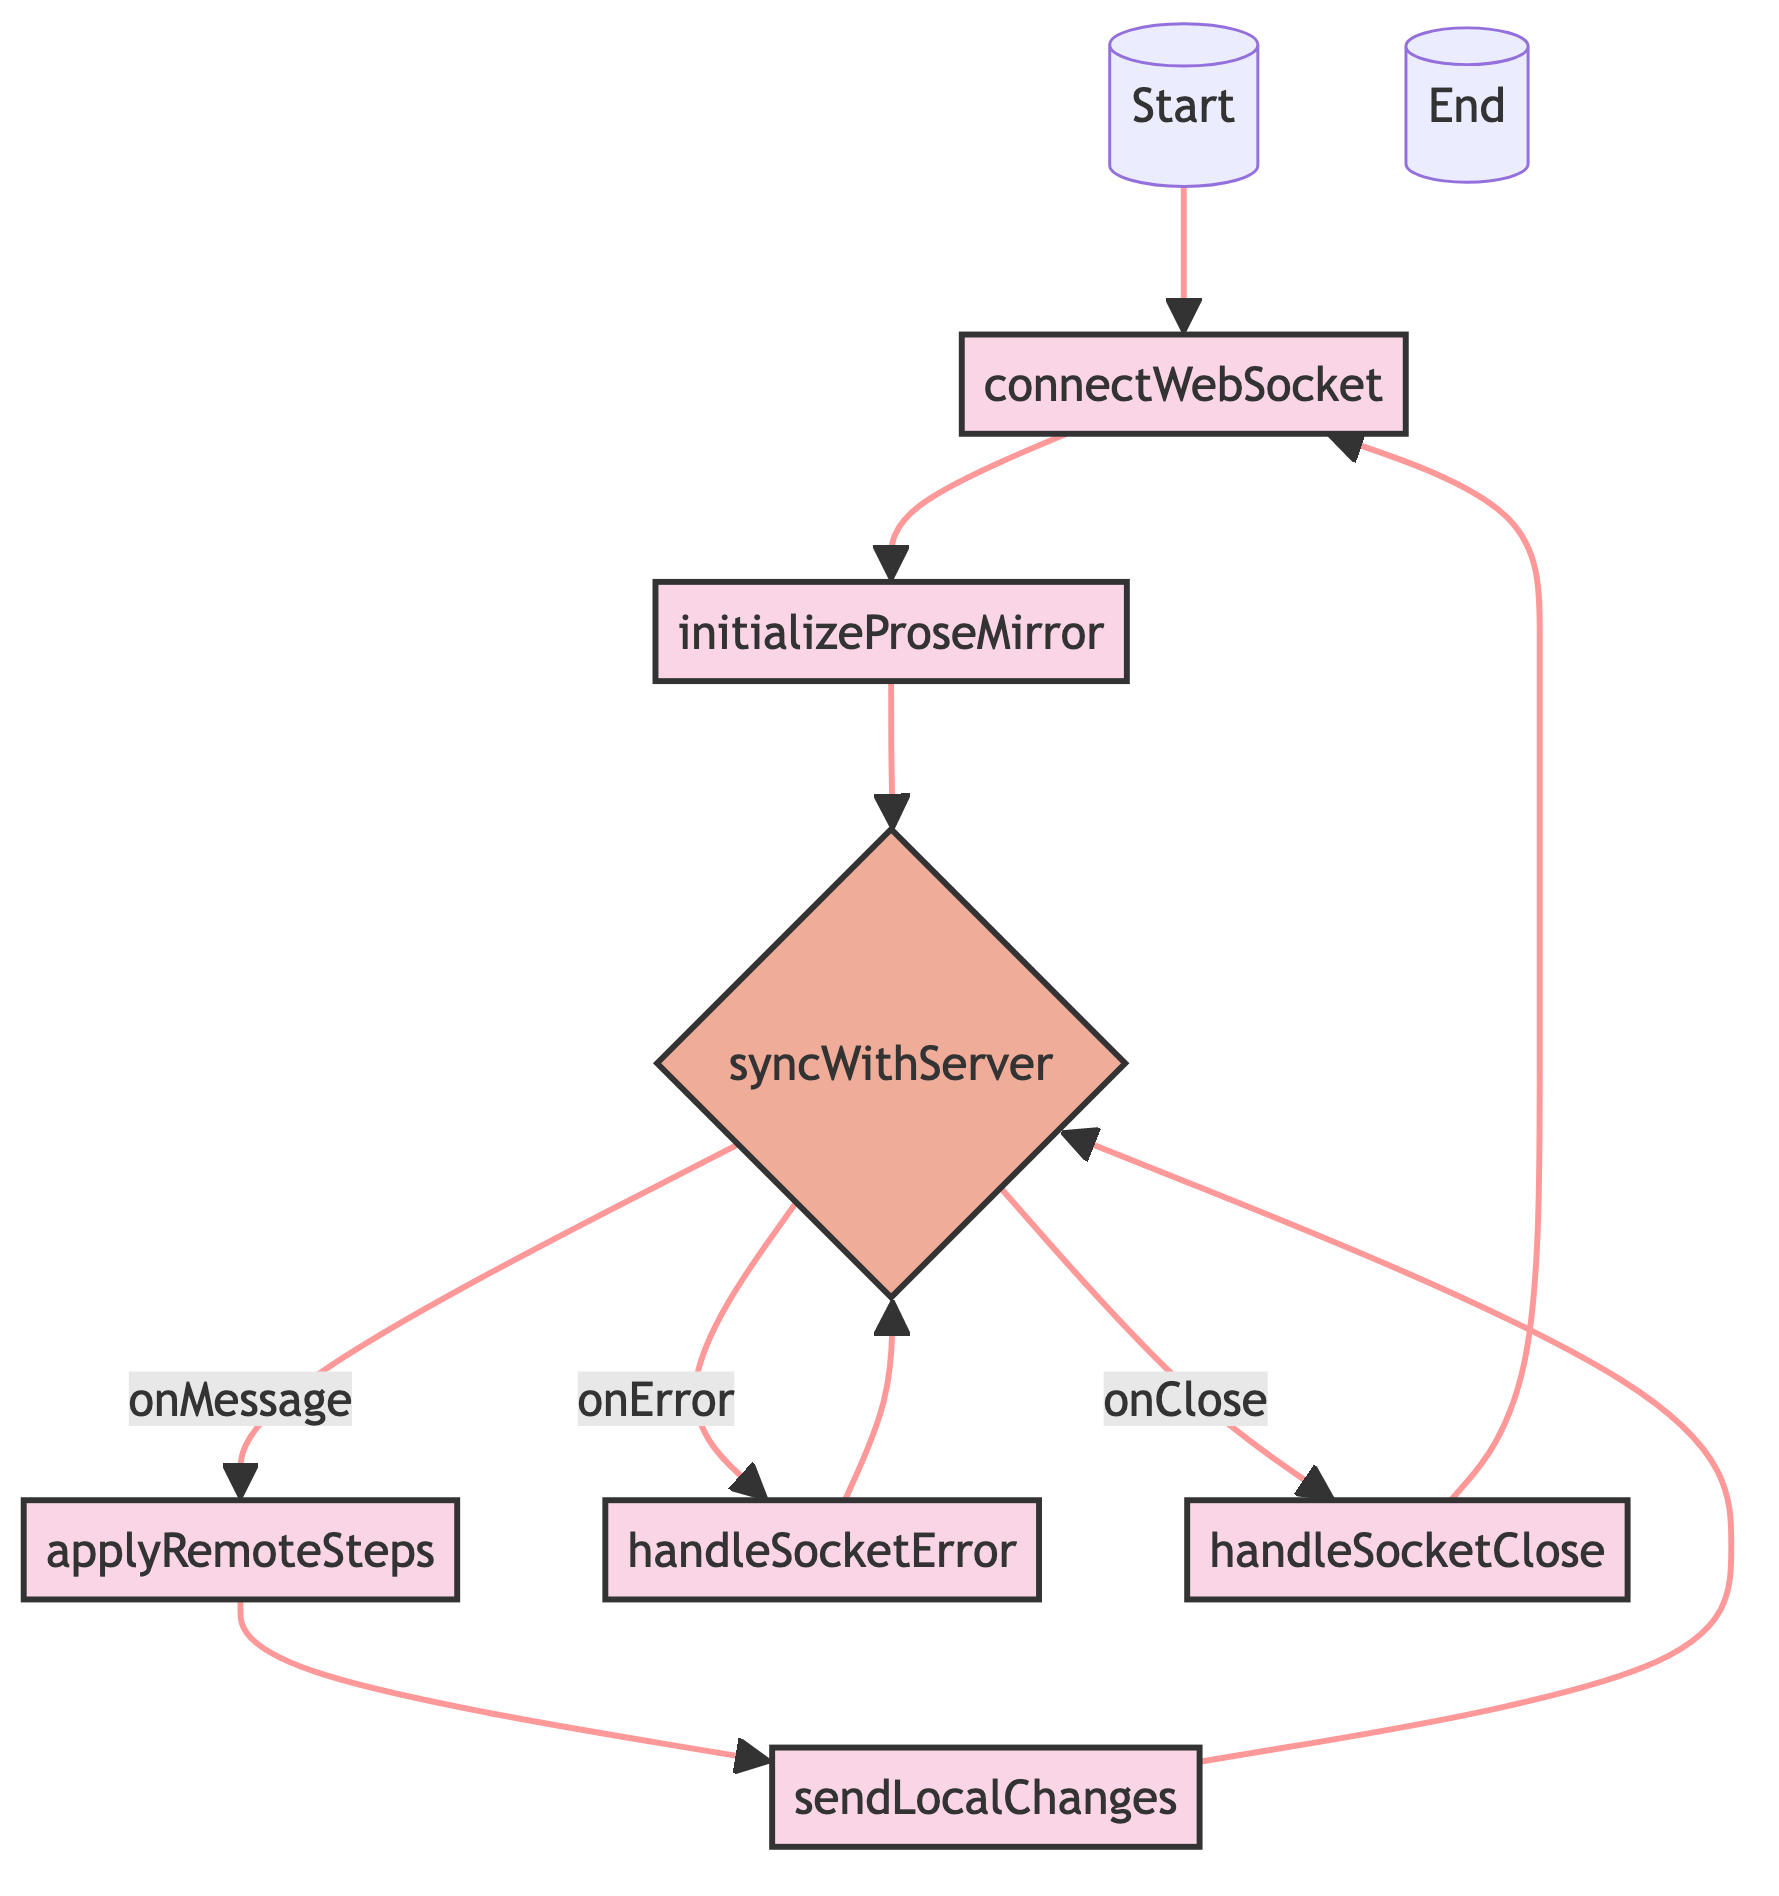What is the first action in the flowchart? The flowchart starts with the node "connectWebSocket," which is the first action taken to establish a WebSocket connection.
Answer: connectWebSocket How many actions are present in the flowchart? The flowchart has six actions: connectWebSocket, initializeProseMirror, applyRemoteSteps, sendLocalChanges, handleSocketError, and handleSocketClose.
Answer: six What happens after initializing ProseMirror? After initializing ProseMirror, the next step is to sync with the server using the "syncWithServer" decision node.
Answer: syncWithServer What is the action taken when a message is received from the server? When a message is received, the action taken is "applyRemoteSteps," which applies remote steps to the local ProseMirror editor.
Answer: applyRemoteSteps What do we do when the WebSocket connection encounters an error? In case of a WebSocket error, the action "handleSocketError" is executed to log or display error messages.
Answer: handleSocketError Which node do we return to after handling a socket closure? After handling a socket closure with "handleSocketClose," we return to the "connectWebSocket" to attempt reconnection.
Answer: connectWebSocket What does the 'sendLocalChanges' action do? The 'sendLocalChanges' action monitors changes in the local editor and sends those changes to the server.
Answer: Monitor local editor changes What type of node is 'syncWithServer'? 'syncWithServer' is a switch node because it has multiple cases (onMessage, onError, onClose) that dictate different actions based on the server's state.
Answer: switch What happens after 'applyRemoteSteps'? After 'applyRemoteSteps', the flow continues to 'sendLocalChanges' to continue monitoring the editor for further changes.
Answer: sendLocalChanges 